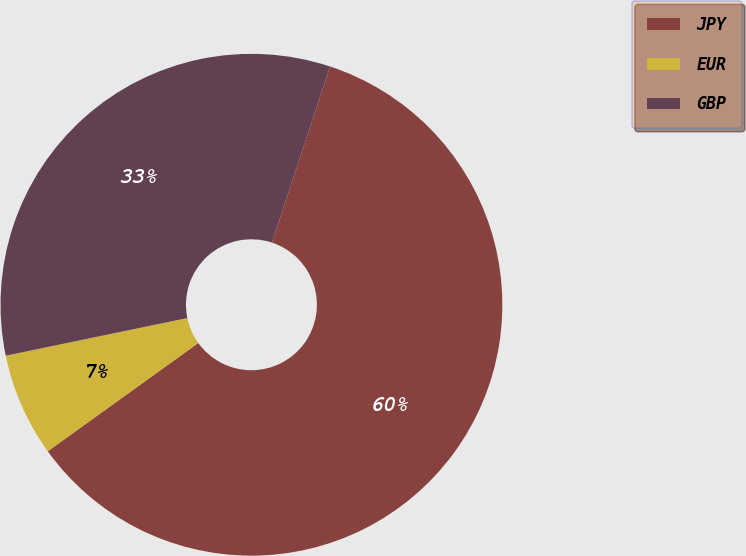Convert chart to OTSL. <chart><loc_0><loc_0><loc_500><loc_500><pie_chart><fcel>JPY<fcel>EUR<fcel>GBP<nl><fcel>60.0%<fcel>6.67%<fcel>33.33%<nl></chart> 